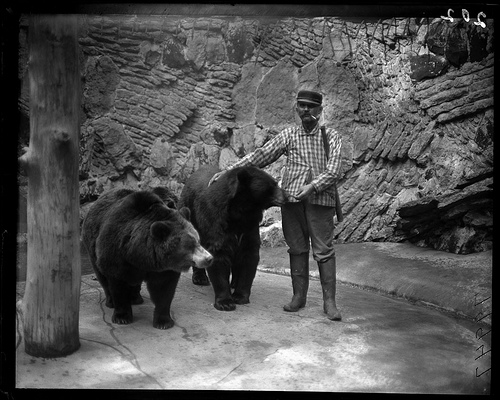How many bears are in the photo? There are two bears present in the photo, both appearing to be quite large and are likely adults. They're accompanied by a person, indicating this might be a controlled environment like a sanctuary or zoo. 